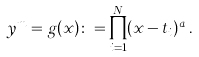Convert formula to latex. <formula><loc_0><loc_0><loc_500><loc_500>y ^ { m } = g ( x ) \colon = \prod _ { i = 1 } ^ { N } ( x - t _ { i } ) ^ { a _ { i } } .</formula> 